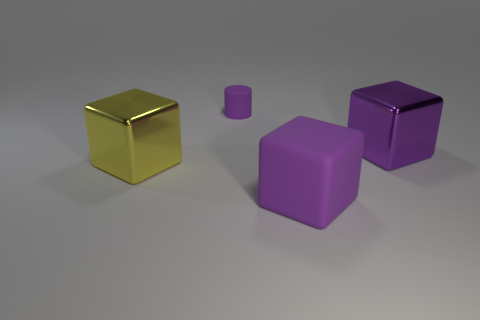Does the tiny rubber thing have the same color as the matte block?
Provide a succinct answer. Yes. There is a purple object behind the purple metallic block; what shape is it?
Keep it short and to the point. Cylinder. What is the material of the purple cube that is the same size as the purple metallic object?
Give a very brief answer. Rubber. How many objects are either purple cubes that are in front of the yellow cube or big shiny things to the right of the yellow block?
Ensure brevity in your answer.  2. There is a purple block that is made of the same material as the small object; what is its size?
Your answer should be compact. Large. What number of rubber objects are purple things or large purple spheres?
Your answer should be very brief. 2. The purple cylinder has what size?
Keep it short and to the point. Small. Is the matte cube the same size as the yellow shiny cube?
Give a very brief answer. Yes. There is a big object on the left side of the tiny purple matte cylinder; what material is it?
Make the answer very short. Metal. There is another purple thing that is the same shape as the big matte object; what is its material?
Your response must be concise. Metal. 